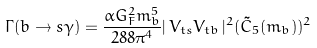Convert formula to latex. <formula><loc_0><loc_0><loc_500><loc_500>\Gamma ( b \rightarrow s \gamma ) = \frac { \alpha G _ { F } ^ { 2 } m _ { b } ^ { 5 } } { 2 8 8 \pi ^ { 4 } } | \, V _ { t s } V _ { t b } \, | ^ { 2 } ( \tilde { C } _ { 5 } ( m _ { b } ) ) ^ { 2 }</formula> 